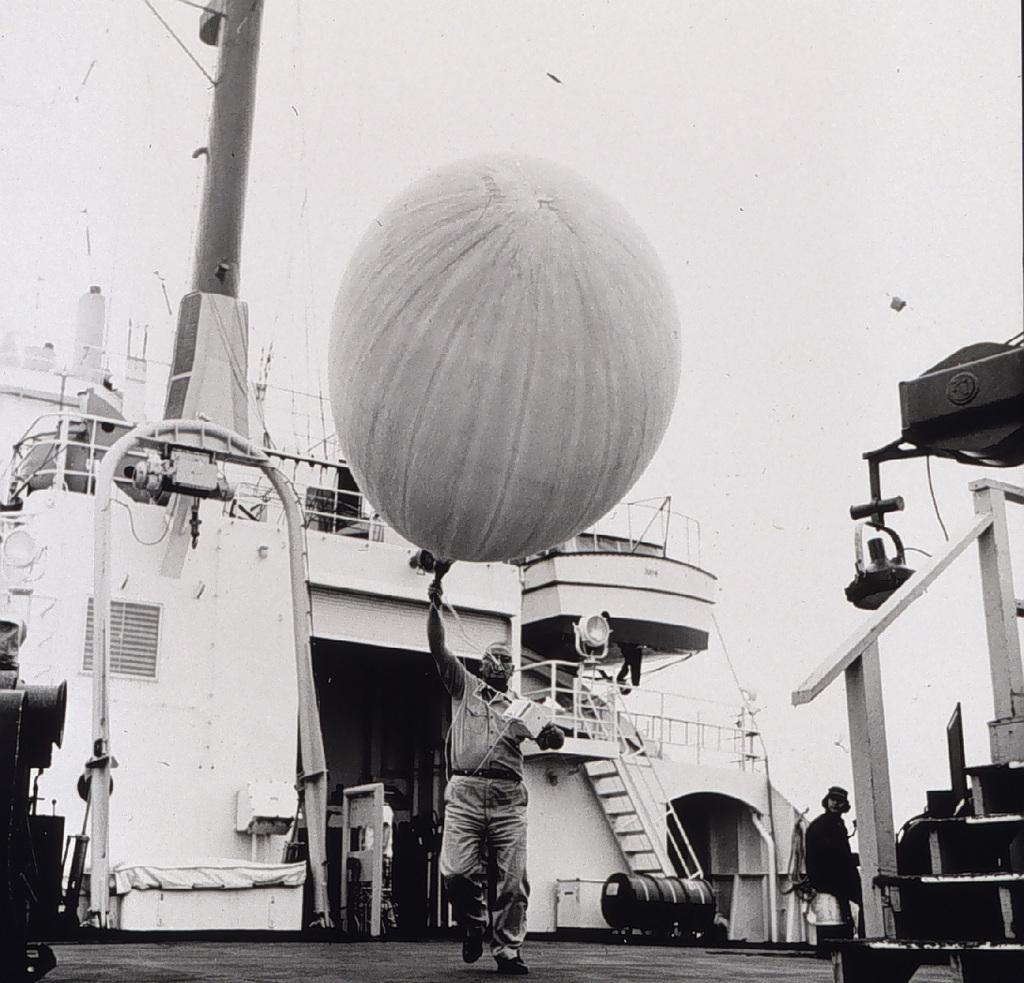What can be seen in the image that is related to transportation? There are ships in the image. Can you describe the person seated in the image? A human is seated in the image. What object is the man holding in his hand? A man is holding a balloon in his hand. What type of apple can be seen on the window in the image? There is no apple or window present in the image. What smell is associated with the balloon in the image? The image does not provide any information about the smell of the balloon. 